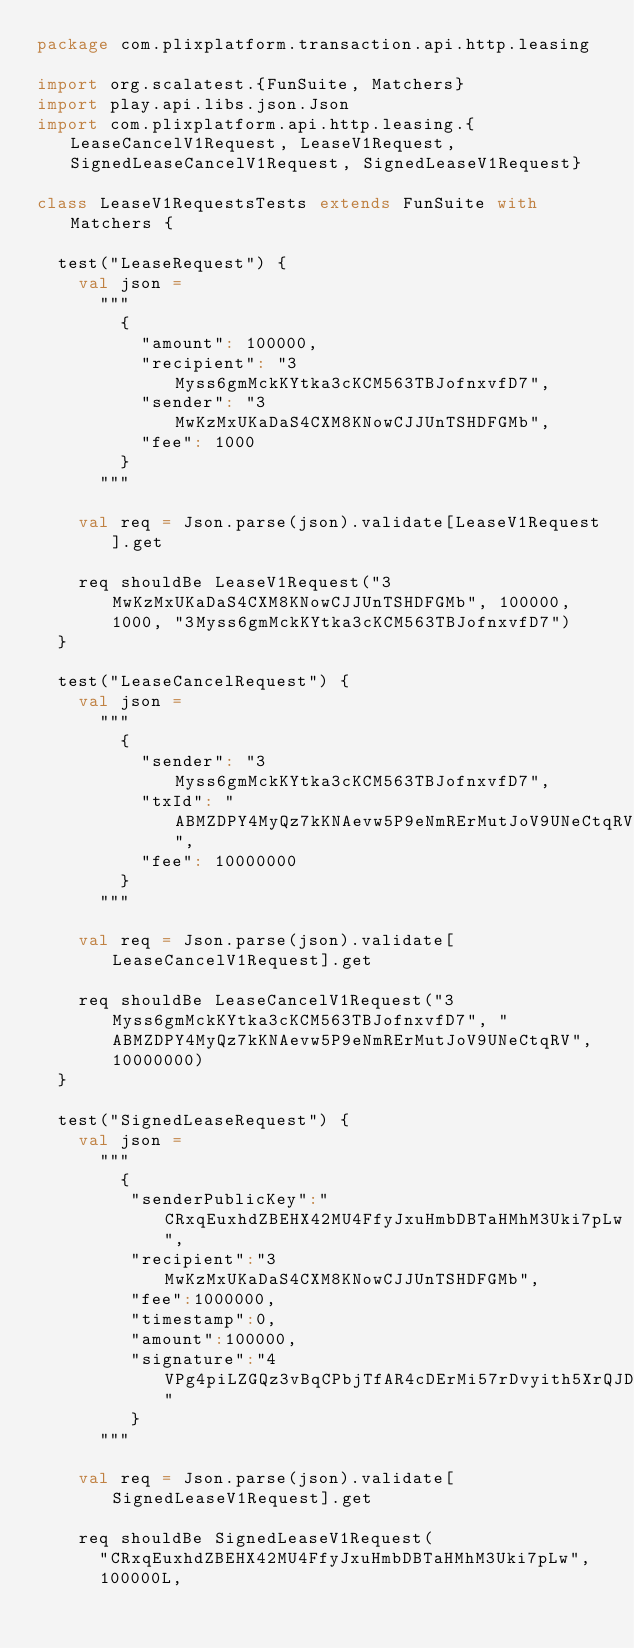Convert code to text. <code><loc_0><loc_0><loc_500><loc_500><_Scala_>package com.plixplatform.transaction.api.http.leasing

import org.scalatest.{FunSuite, Matchers}
import play.api.libs.json.Json
import com.plixplatform.api.http.leasing.{LeaseCancelV1Request, LeaseV1Request, SignedLeaseCancelV1Request, SignedLeaseV1Request}

class LeaseV1RequestsTests extends FunSuite with Matchers {

  test("LeaseRequest") {
    val json =
      """
        {
          "amount": 100000,
          "recipient": "3Myss6gmMckKYtka3cKCM563TBJofnxvfD7",
          "sender": "3MwKzMxUKaDaS4CXM8KNowCJJUnTSHDFGMb",
          "fee": 1000
        }
      """

    val req = Json.parse(json).validate[LeaseV1Request].get

    req shouldBe LeaseV1Request("3MwKzMxUKaDaS4CXM8KNowCJJUnTSHDFGMb", 100000, 1000, "3Myss6gmMckKYtka3cKCM563TBJofnxvfD7")
  }

  test("LeaseCancelRequest") {
    val json =
      """
        {
          "sender": "3Myss6gmMckKYtka3cKCM563TBJofnxvfD7",
          "txId": "ABMZDPY4MyQz7kKNAevw5P9eNmRErMutJoV9UNeCtqRV",
          "fee": 10000000
        }
      """

    val req = Json.parse(json).validate[LeaseCancelV1Request].get

    req shouldBe LeaseCancelV1Request("3Myss6gmMckKYtka3cKCM563TBJofnxvfD7", "ABMZDPY4MyQz7kKNAevw5P9eNmRErMutJoV9UNeCtqRV", 10000000)
  }

  test("SignedLeaseRequest") {
    val json =
      """
        {
         "senderPublicKey":"CRxqEuxhdZBEHX42MU4FfyJxuHmbDBTaHMhM3Uki7pLw",
         "recipient":"3MwKzMxUKaDaS4CXM8KNowCJJUnTSHDFGMb",
         "fee":1000000,
         "timestamp":0,
         "amount":100000,
         "signature":"4VPg4piLZGQz3vBqCPbjTfAR4cDErMi57rDvyith5XrQJDLryU2w2JsL3p4ejEqTPpctZ5YekpQwZPTtYiGo5yPC"
         }
      """

    val req = Json.parse(json).validate[SignedLeaseV1Request].get

    req shouldBe SignedLeaseV1Request(
      "CRxqEuxhdZBEHX42MU4FfyJxuHmbDBTaHMhM3Uki7pLw",
      100000L,</code> 